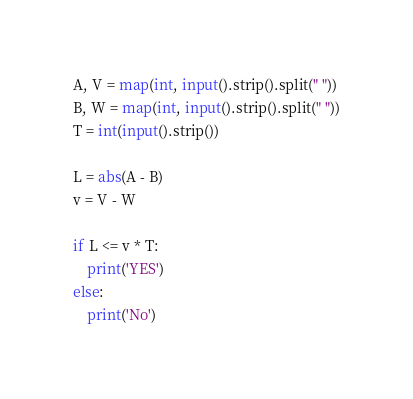Convert code to text. <code><loc_0><loc_0><loc_500><loc_500><_Python_>A, V = map(int, input().strip().split(" "))
B, W = map(int, input().strip().split(" "))
T = int(input().strip())

L = abs(A - B)
v = V - W

if L <= v * T:
    print('YES')
else:
    print('No')
</code> 